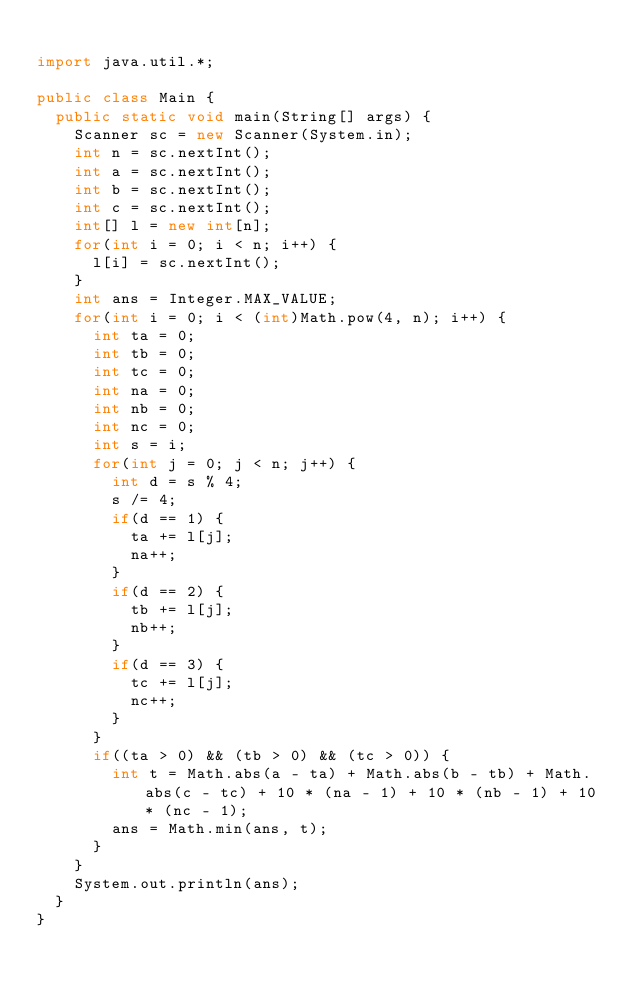Convert code to text. <code><loc_0><loc_0><loc_500><loc_500><_Java_>
import java.util.*;

public class Main {
  public static void main(String[] args) {
    Scanner sc = new Scanner(System.in);
    int n = sc.nextInt();
    int a = sc.nextInt();
    int b = sc.nextInt();
    int c = sc.nextInt();
    int[] l = new int[n];
    for(int i = 0; i < n; i++) {
      l[i] = sc.nextInt();
    }
    int ans = Integer.MAX_VALUE;
    for(int i = 0; i < (int)Math.pow(4, n); i++) {
      int ta = 0;
      int tb = 0;
      int tc = 0;
      int na = 0;
      int nb = 0;
      int nc = 0;
      int s = i;
      for(int j = 0; j < n; j++) {
        int d = s % 4;
        s /= 4;
        if(d == 1) {
          ta += l[j];
          na++;
        }
        if(d == 2) {
          tb += l[j];
          nb++;
        }
        if(d == 3) {
          tc += l[j];
          nc++;
        }
      }
      if((ta > 0) && (tb > 0) && (tc > 0)) {
        int t = Math.abs(a - ta) + Math.abs(b - tb) + Math.abs(c - tc) + 10 * (na - 1) + 10 * (nb - 1) + 10 * (nc - 1);
        ans = Math.min(ans, t);
      }
    }
    System.out.println(ans);
  }
}
</code> 